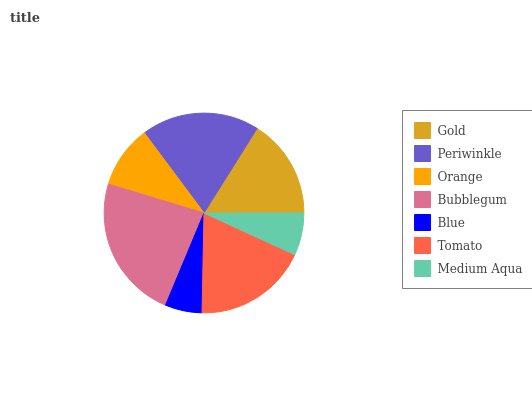Is Blue the minimum?
Answer yes or no. Yes. Is Bubblegum the maximum?
Answer yes or no. Yes. Is Periwinkle the minimum?
Answer yes or no. No. Is Periwinkle the maximum?
Answer yes or no. No. Is Periwinkle greater than Gold?
Answer yes or no. Yes. Is Gold less than Periwinkle?
Answer yes or no. Yes. Is Gold greater than Periwinkle?
Answer yes or no. No. Is Periwinkle less than Gold?
Answer yes or no. No. Is Gold the high median?
Answer yes or no. Yes. Is Gold the low median?
Answer yes or no. Yes. Is Blue the high median?
Answer yes or no. No. Is Bubblegum the low median?
Answer yes or no. No. 